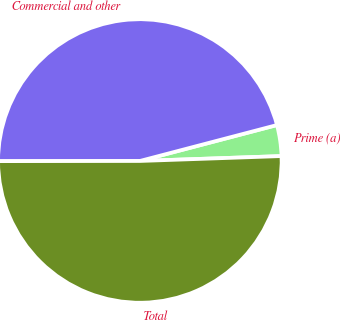Convert chart to OTSL. <chart><loc_0><loc_0><loc_500><loc_500><pie_chart><fcel>Prime (a)<fcel>Commercial and other<fcel>Total<nl><fcel>3.53%<fcel>45.94%<fcel>50.53%<nl></chart> 